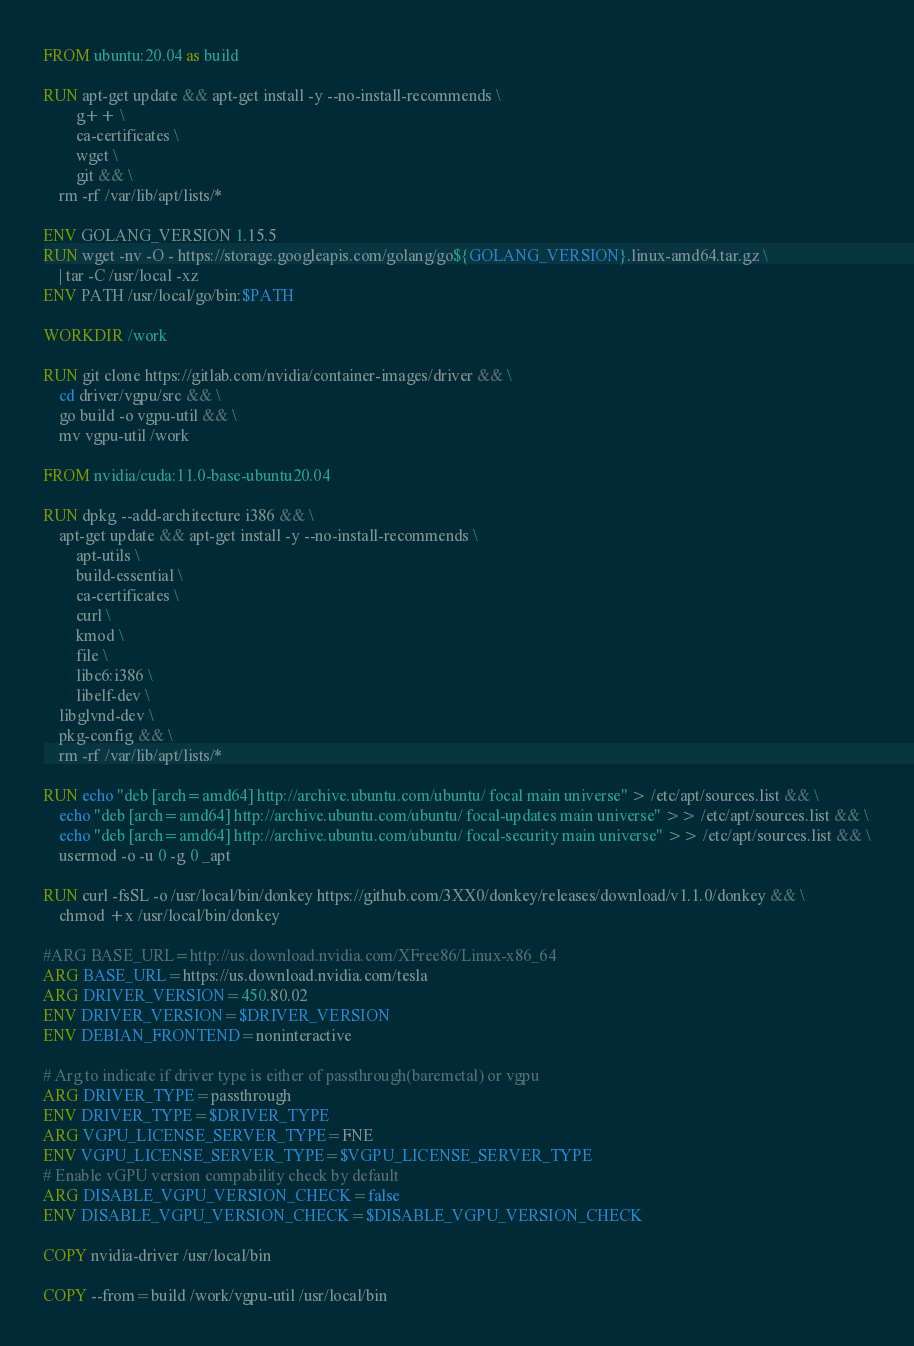Convert code to text. <code><loc_0><loc_0><loc_500><loc_500><_Dockerfile_>FROM ubuntu:20.04 as build

RUN apt-get update && apt-get install -y --no-install-recommends \
        g++ \
        ca-certificates \
        wget \
        git && \
    rm -rf /var/lib/apt/lists/*

ENV GOLANG_VERSION 1.15.5
RUN wget -nv -O - https://storage.googleapis.com/golang/go${GOLANG_VERSION}.linux-amd64.tar.gz \
    | tar -C /usr/local -xz
ENV PATH /usr/local/go/bin:$PATH

WORKDIR /work

RUN git clone https://gitlab.com/nvidia/container-images/driver && \
    cd driver/vgpu/src && \
    go build -o vgpu-util && \
    mv vgpu-util /work

FROM nvidia/cuda:11.0-base-ubuntu20.04

RUN dpkg --add-architecture i386 && \
    apt-get update && apt-get install -y --no-install-recommends \
        apt-utils \
        build-essential \
        ca-certificates \
        curl \
        kmod \
        file \
        libc6:i386 \
        libelf-dev \
	libglvnd-dev \
	pkg-config && \
    rm -rf /var/lib/apt/lists/*

RUN echo "deb [arch=amd64] http://archive.ubuntu.com/ubuntu/ focal main universe" > /etc/apt/sources.list && \
    echo "deb [arch=amd64] http://archive.ubuntu.com/ubuntu/ focal-updates main universe" >> /etc/apt/sources.list && \
    echo "deb [arch=amd64] http://archive.ubuntu.com/ubuntu/ focal-security main universe" >> /etc/apt/sources.list && \
    usermod -o -u 0 -g 0 _apt

RUN curl -fsSL -o /usr/local/bin/donkey https://github.com/3XX0/donkey/releases/download/v1.1.0/donkey && \
    chmod +x /usr/local/bin/donkey

#ARG BASE_URL=http://us.download.nvidia.com/XFree86/Linux-x86_64
ARG BASE_URL=https://us.download.nvidia.com/tesla
ARG DRIVER_VERSION=450.80.02
ENV DRIVER_VERSION=$DRIVER_VERSION
ENV DEBIAN_FRONTEND=noninteractive

# Arg to indicate if driver type is either of passthrough(baremetal) or vgpu
ARG DRIVER_TYPE=passthrough
ENV DRIVER_TYPE=$DRIVER_TYPE
ARG VGPU_LICENSE_SERVER_TYPE=FNE
ENV VGPU_LICENSE_SERVER_TYPE=$VGPU_LICENSE_SERVER_TYPE
# Enable vGPU version compability check by default
ARG DISABLE_VGPU_VERSION_CHECK=false
ENV DISABLE_VGPU_VERSION_CHECK=$DISABLE_VGPU_VERSION_CHECK

COPY nvidia-driver /usr/local/bin

COPY --from=build /work/vgpu-util /usr/local/bin
</code> 